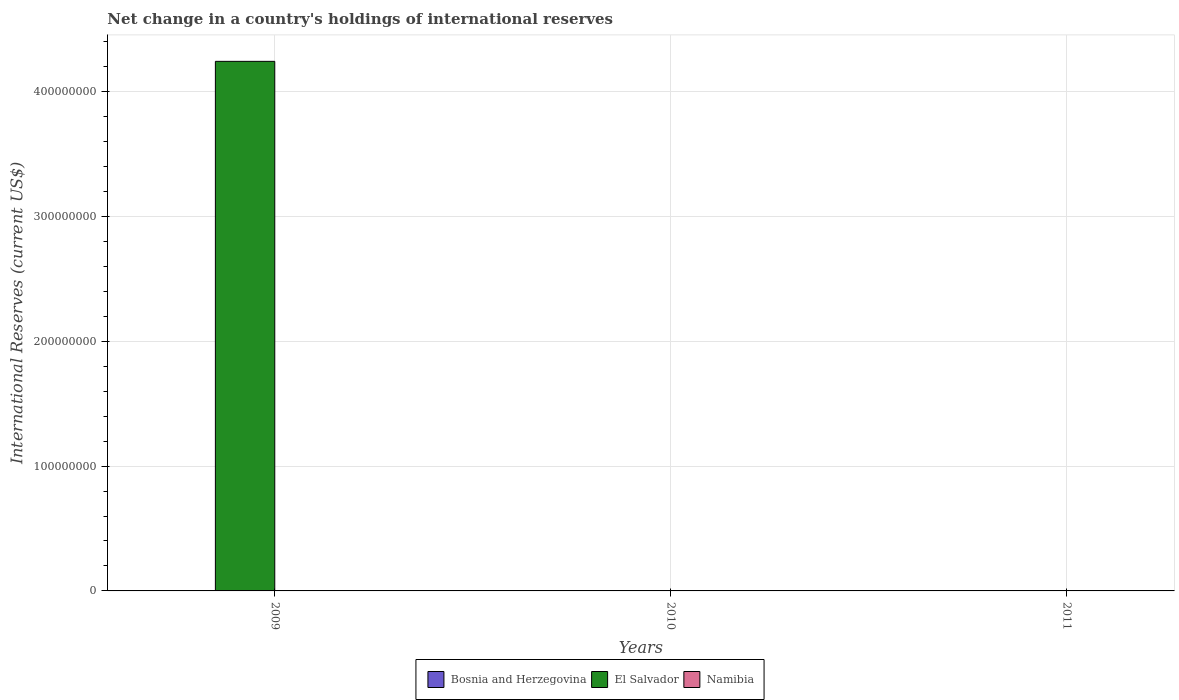How many different coloured bars are there?
Make the answer very short. 1. Are the number of bars per tick equal to the number of legend labels?
Give a very brief answer. No. What is the label of the 1st group of bars from the left?
Give a very brief answer. 2009. In how many cases, is the number of bars for a given year not equal to the number of legend labels?
Keep it short and to the point. 3. Across all years, what is the maximum international reserves in El Salvador?
Your answer should be very brief. 4.24e+08. In which year was the international reserves in El Salvador maximum?
Provide a short and direct response. 2009. What is the total international reserves in El Salvador in the graph?
Keep it short and to the point. 4.24e+08. What is the difference between the international reserves in Bosnia and Herzegovina in 2010 and the international reserves in El Salvador in 2009?
Offer a very short reply. -4.24e+08. What is the difference between the highest and the lowest international reserves in El Salvador?
Give a very brief answer. 4.24e+08. In how many years, is the international reserves in Bosnia and Herzegovina greater than the average international reserves in Bosnia and Herzegovina taken over all years?
Your answer should be compact. 0. Is it the case that in every year, the sum of the international reserves in Bosnia and Herzegovina and international reserves in El Salvador is greater than the international reserves in Namibia?
Make the answer very short. No. How many bars are there?
Offer a terse response. 1. Are all the bars in the graph horizontal?
Offer a very short reply. No. What is the difference between two consecutive major ticks on the Y-axis?
Make the answer very short. 1.00e+08. Does the graph contain any zero values?
Your answer should be compact. Yes. How many legend labels are there?
Give a very brief answer. 3. How are the legend labels stacked?
Ensure brevity in your answer.  Horizontal. What is the title of the graph?
Offer a very short reply. Net change in a country's holdings of international reserves. What is the label or title of the Y-axis?
Keep it short and to the point. International Reserves (current US$). What is the International Reserves (current US$) of Bosnia and Herzegovina in 2009?
Your response must be concise. 0. What is the International Reserves (current US$) of El Salvador in 2009?
Your response must be concise. 4.24e+08. What is the International Reserves (current US$) in Namibia in 2009?
Keep it short and to the point. 0. What is the International Reserves (current US$) in El Salvador in 2010?
Keep it short and to the point. 0. What is the International Reserves (current US$) of Bosnia and Herzegovina in 2011?
Make the answer very short. 0. What is the International Reserves (current US$) of El Salvador in 2011?
Make the answer very short. 0. Across all years, what is the maximum International Reserves (current US$) of El Salvador?
Keep it short and to the point. 4.24e+08. What is the total International Reserves (current US$) of El Salvador in the graph?
Offer a very short reply. 4.24e+08. What is the total International Reserves (current US$) of Namibia in the graph?
Offer a terse response. 0. What is the average International Reserves (current US$) of El Salvador per year?
Provide a short and direct response. 1.41e+08. What is the difference between the highest and the lowest International Reserves (current US$) of El Salvador?
Provide a short and direct response. 4.24e+08. 